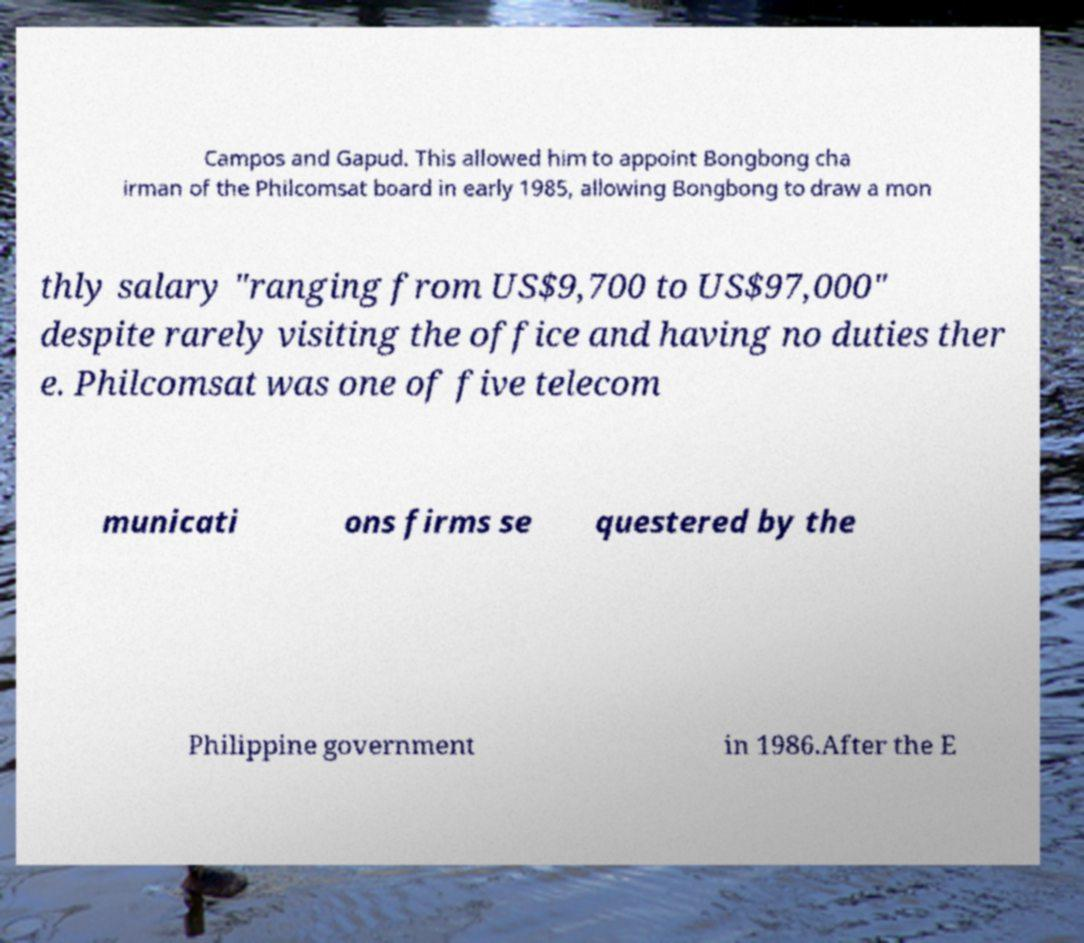Please identify and transcribe the text found in this image. Campos and Gapud. This allowed him to appoint Bongbong cha irman of the Philcomsat board in early 1985, allowing Bongbong to draw a mon thly salary "ranging from US$9,700 to US$97,000" despite rarely visiting the office and having no duties ther e. Philcomsat was one of five telecom municati ons firms se questered by the Philippine government in 1986.After the E 